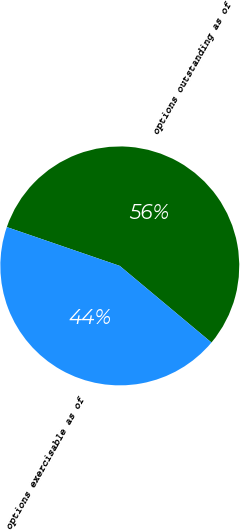Convert chart. <chart><loc_0><loc_0><loc_500><loc_500><pie_chart><fcel>options outstanding as of<fcel>options exercisable as of<nl><fcel>55.81%<fcel>44.19%<nl></chart> 